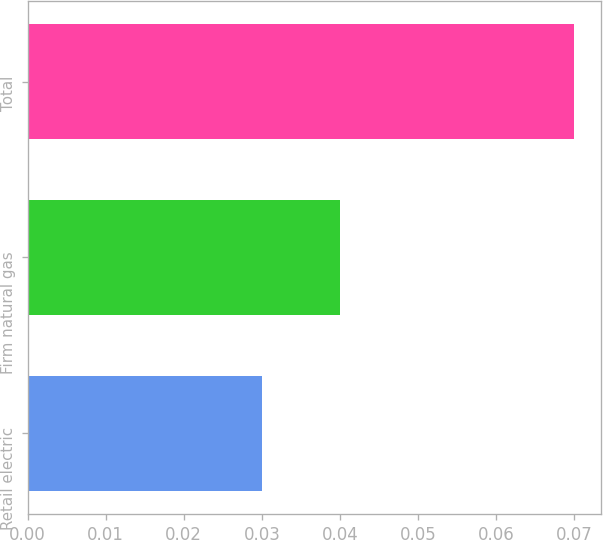Convert chart. <chart><loc_0><loc_0><loc_500><loc_500><bar_chart><fcel>Retail electric<fcel>Firm natural gas<fcel>Total<nl><fcel>0.03<fcel>0.04<fcel>0.07<nl></chart> 